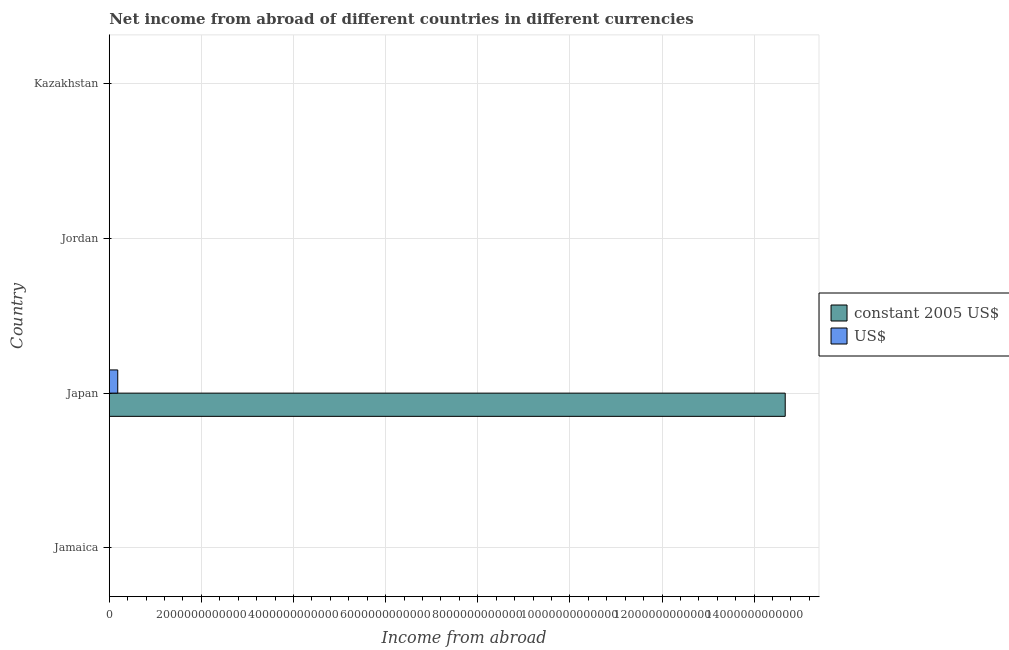Are the number of bars per tick equal to the number of legend labels?
Keep it short and to the point. No. How many bars are there on the 2nd tick from the bottom?
Provide a succinct answer. 2. What is the label of the 2nd group of bars from the top?
Give a very brief answer. Jordan. Across all countries, what is the maximum income from abroad in constant 2005 us$?
Your answer should be very brief. 1.47e+13. Across all countries, what is the minimum income from abroad in us$?
Give a very brief answer. 0. What is the total income from abroad in constant 2005 us$ in the graph?
Offer a terse response. 1.47e+13. What is the difference between the income from abroad in us$ in Japan and the income from abroad in constant 2005 us$ in Jordan?
Your response must be concise. 1.84e+11. What is the average income from abroad in constant 2005 us$ per country?
Offer a very short reply. 3.67e+12. What is the difference between the income from abroad in constant 2005 us$ and income from abroad in us$ in Japan?
Provide a succinct answer. 1.45e+13. In how many countries, is the income from abroad in constant 2005 us$ greater than 10400000000000 units?
Offer a terse response. 1. What is the difference between the highest and the lowest income from abroad in us$?
Your answer should be very brief. 1.84e+11. Are all the bars in the graph horizontal?
Keep it short and to the point. Yes. What is the difference between two consecutive major ticks on the X-axis?
Make the answer very short. 2.00e+12. Does the graph contain any zero values?
Offer a terse response. Yes. Where does the legend appear in the graph?
Offer a very short reply. Center right. What is the title of the graph?
Your answer should be compact. Net income from abroad of different countries in different currencies. What is the label or title of the X-axis?
Offer a very short reply. Income from abroad. What is the Income from abroad of constant 2005 US$ in Jamaica?
Keep it short and to the point. 0. What is the Income from abroad in US$ in Jamaica?
Provide a succinct answer. 0. What is the Income from abroad in constant 2005 US$ in Japan?
Make the answer very short. 1.47e+13. What is the Income from abroad of US$ in Japan?
Provide a short and direct response. 1.84e+11. Across all countries, what is the maximum Income from abroad of constant 2005 US$?
Provide a short and direct response. 1.47e+13. Across all countries, what is the maximum Income from abroad of US$?
Make the answer very short. 1.84e+11. Across all countries, what is the minimum Income from abroad of US$?
Your answer should be compact. 0. What is the total Income from abroad of constant 2005 US$ in the graph?
Your answer should be very brief. 1.47e+13. What is the total Income from abroad of US$ in the graph?
Your response must be concise. 1.84e+11. What is the average Income from abroad of constant 2005 US$ per country?
Provide a succinct answer. 3.67e+12. What is the average Income from abroad in US$ per country?
Provide a succinct answer. 4.60e+1. What is the difference between the Income from abroad of constant 2005 US$ and Income from abroad of US$ in Japan?
Offer a terse response. 1.45e+13. What is the difference between the highest and the lowest Income from abroad in constant 2005 US$?
Your answer should be very brief. 1.47e+13. What is the difference between the highest and the lowest Income from abroad in US$?
Your answer should be very brief. 1.84e+11. 